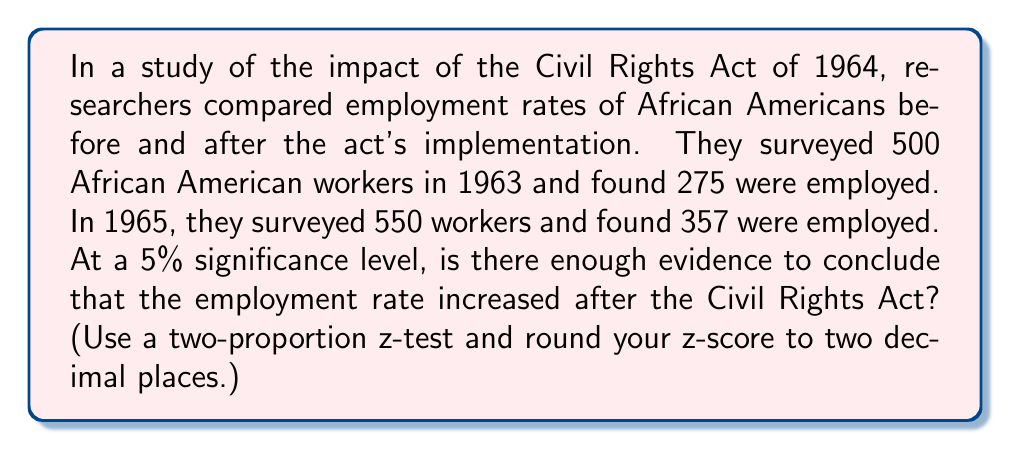Can you solve this math problem? To determine if there's a significant increase in employment rate, we'll use a two-proportion z-test.

Step 1: Define hypotheses
$H_0: p_1 = p_2$ (null hypothesis)
$H_a: p_1 < p_2$ (alternative hypothesis, one-tailed test)

Where $p_1$ is the proportion employed in 1963 and $p_2$ is the proportion employed in 1965.

Step 2: Calculate sample proportions
$\hat{p}_1 = \frac{275}{500} = 0.55$
$\hat{p}_2 = \frac{357}{550} = 0.6491$

Step 3: Calculate pooled proportion
$\hat{p} = \frac{275 + 357}{500 + 550} = \frac{632}{1050} = 0.6019$

Step 4: Calculate the z-score
$$z = \frac{\hat{p}_2 - \hat{p}_1}{\sqrt{\hat{p}(1-\hat{p})(\frac{1}{n_1} + \frac{1}{n_2})}}$$

$$z = \frac{0.6491 - 0.55}{\sqrt{0.6019(1-0.6019)(\frac{1}{500} + \frac{1}{550})}} = 3.33$$

Step 5: Find the critical value
For a one-tailed test at 5% significance level, the critical z-value is 1.645.

Step 6: Compare z-score to critical value
Since 3.33 > 1.645, we reject the null hypothesis.

Therefore, there is enough evidence to conclude that the employment rate increased after the Civil Rights Act at a 5% significance level.
Answer: Yes, significant increase (z = 3.33 > 1.645) 